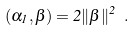<formula> <loc_0><loc_0><loc_500><loc_500>( \alpha _ { 1 } , \beta ) = 2 \| \beta \| ^ { 2 } \ .</formula> 